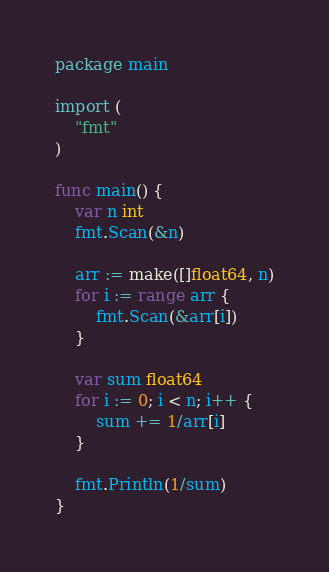Convert code to text. <code><loc_0><loc_0><loc_500><loc_500><_Go_>package main

import (
	"fmt"
)

func main() {
	var n int
	fmt.Scan(&n)

	arr := make([]float64, n)
	for i := range arr {
		fmt.Scan(&arr[i])
	}

	var sum float64
	for i := 0; i < n; i++ {
		sum += 1/arr[i]
	}

	fmt.Println(1/sum)
}
</code> 